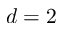<formula> <loc_0><loc_0><loc_500><loc_500>d = 2</formula> 